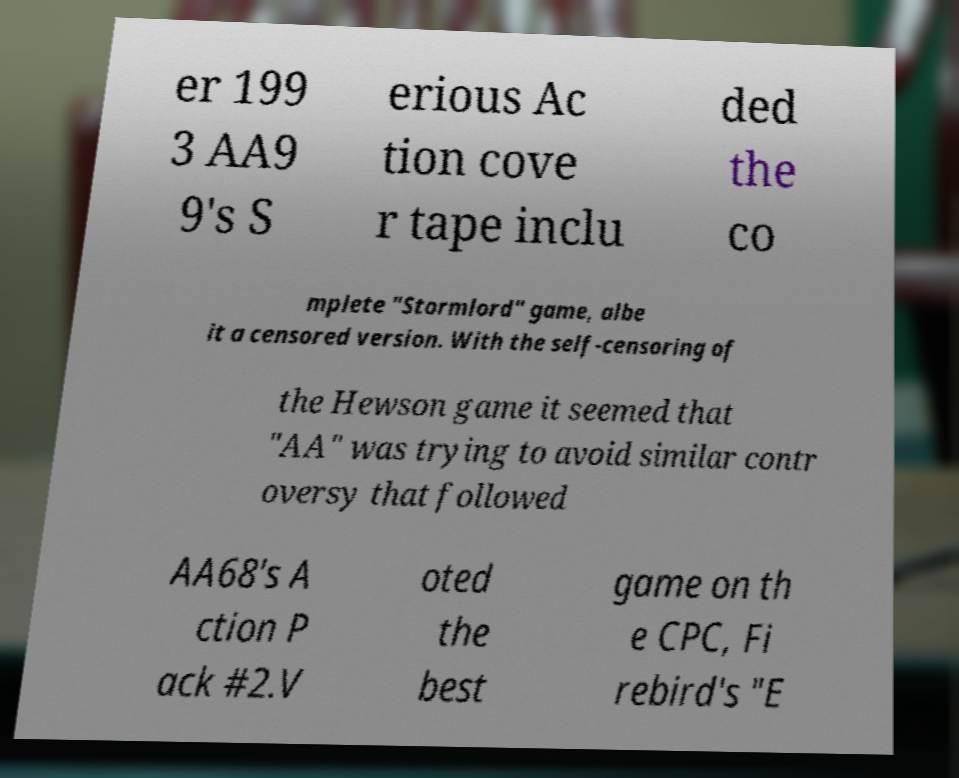Can you accurately transcribe the text from the provided image for me? er 199 3 AA9 9's S erious Ac tion cove r tape inclu ded the co mplete "Stormlord" game, albe it a censored version. With the self-censoring of the Hewson game it seemed that "AA" was trying to avoid similar contr oversy that followed AA68's A ction P ack #2.V oted the best game on th e CPC, Fi rebird's "E 